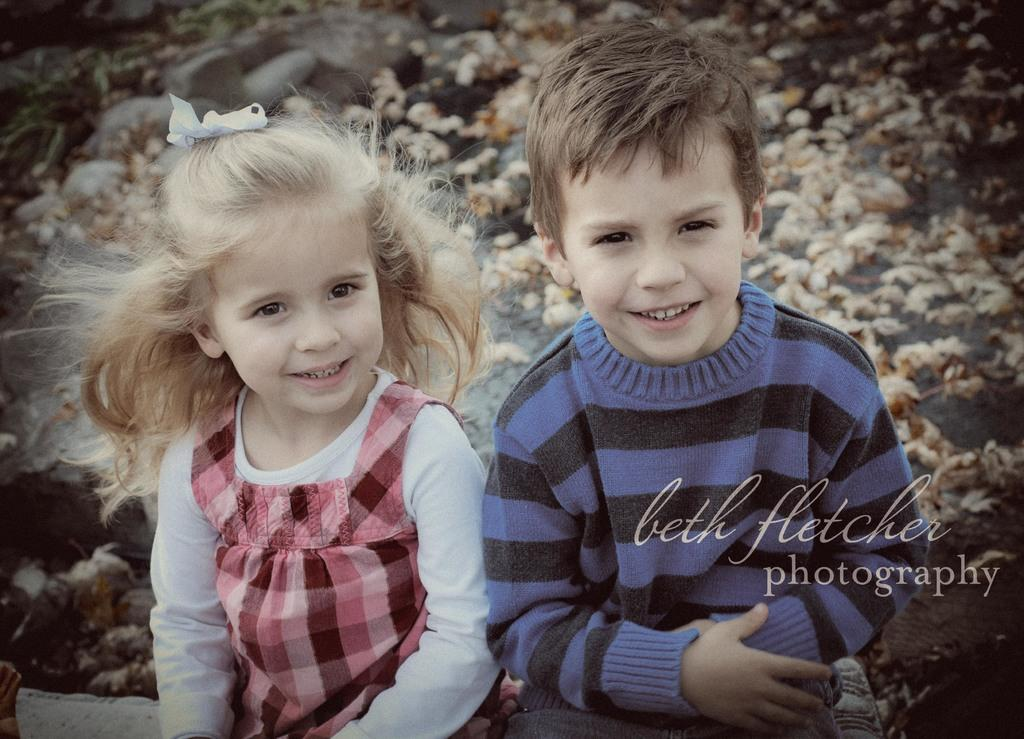Who are the subjects in the image? There is a boy and a girl in the image. What are the boy and girl doing in the image? The boy and girl are sitting. What are the boy and girl wearing in the image? The boy and girl are wearing clothes. What type of donkey can be seen in the image? There is no donkey present in the image. What is the birth date of the boy in the image? The provided facts do not include any information about the birth date of the boy or girl. 